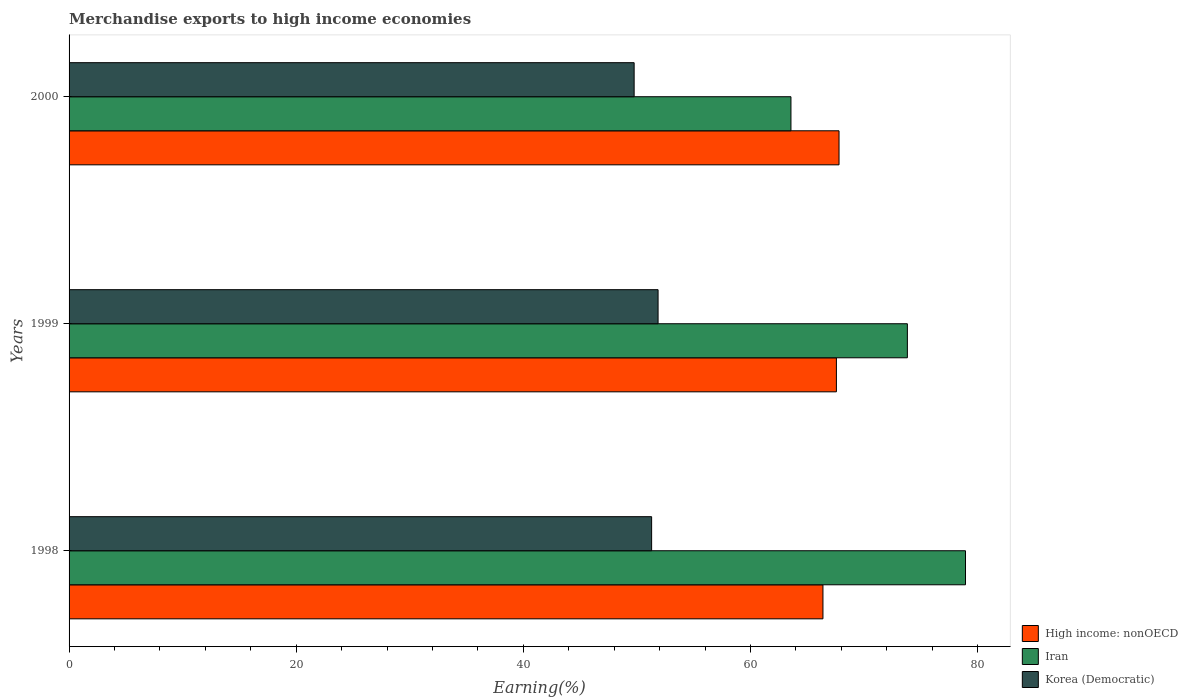How many bars are there on the 1st tick from the top?
Give a very brief answer. 3. What is the label of the 1st group of bars from the top?
Provide a succinct answer. 2000. In how many cases, is the number of bars for a given year not equal to the number of legend labels?
Offer a very short reply. 0. What is the percentage of amount earned from merchandise exports in Iran in 1998?
Keep it short and to the point. 78.93. Across all years, what is the maximum percentage of amount earned from merchandise exports in Korea (Democratic)?
Offer a terse response. 51.86. Across all years, what is the minimum percentage of amount earned from merchandise exports in Korea (Democratic)?
Your response must be concise. 49.75. What is the total percentage of amount earned from merchandise exports in Korea (Democratic) in the graph?
Offer a very short reply. 152.9. What is the difference between the percentage of amount earned from merchandise exports in High income: nonOECD in 1998 and that in 2000?
Your answer should be compact. -1.42. What is the difference between the percentage of amount earned from merchandise exports in Korea (Democratic) in 2000 and the percentage of amount earned from merchandise exports in High income: nonOECD in 1999?
Ensure brevity in your answer.  -17.81. What is the average percentage of amount earned from merchandise exports in High income: nonOECD per year?
Your answer should be compact. 67.24. In the year 1999, what is the difference between the percentage of amount earned from merchandise exports in Korea (Democratic) and percentage of amount earned from merchandise exports in High income: nonOECD?
Give a very brief answer. -15.7. What is the ratio of the percentage of amount earned from merchandise exports in Korea (Democratic) in 1998 to that in 1999?
Your response must be concise. 0.99. Is the difference between the percentage of amount earned from merchandise exports in Korea (Democratic) in 1999 and 2000 greater than the difference between the percentage of amount earned from merchandise exports in High income: nonOECD in 1999 and 2000?
Give a very brief answer. Yes. What is the difference between the highest and the second highest percentage of amount earned from merchandise exports in Korea (Democratic)?
Offer a very short reply. 0.57. What is the difference between the highest and the lowest percentage of amount earned from merchandise exports in Korea (Democratic)?
Keep it short and to the point. 2.11. Is the sum of the percentage of amount earned from merchandise exports in Korea (Democratic) in 1999 and 2000 greater than the maximum percentage of amount earned from merchandise exports in High income: nonOECD across all years?
Your response must be concise. Yes. What does the 2nd bar from the top in 2000 represents?
Offer a very short reply. Iran. What does the 1st bar from the bottom in 2000 represents?
Your answer should be very brief. High income: nonOECD. How many bars are there?
Your answer should be very brief. 9. How many years are there in the graph?
Give a very brief answer. 3. What is the difference between two consecutive major ticks on the X-axis?
Give a very brief answer. 20. Are the values on the major ticks of X-axis written in scientific E-notation?
Your answer should be compact. No. Does the graph contain grids?
Your answer should be compact. No. What is the title of the graph?
Offer a terse response. Merchandise exports to high income economies. Does "Panama" appear as one of the legend labels in the graph?
Offer a very short reply. No. What is the label or title of the X-axis?
Your answer should be very brief. Earning(%). What is the label or title of the Y-axis?
Provide a short and direct response. Years. What is the Earning(%) in High income: nonOECD in 1998?
Give a very brief answer. 66.38. What is the Earning(%) of Iran in 1998?
Ensure brevity in your answer.  78.93. What is the Earning(%) in Korea (Democratic) in 1998?
Your answer should be compact. 51.29. What is the Earning(%) in High income: nonOECD in 1999?
Your answer should be very brief. 67.56. What is the Earning(%) in Iran in 1999?
Ensure brevity in your answer.  73.81. What is the Earning(%) of Korea (Democratic) in 1999?
Your answer should be compact. 51.86. What is the Earning(%) of High income: nonOECD in 2000?
Ensure brevity in your answer.  67.79. What is the Earning(%) in Iran in 2000?
Provide a short and direct response. 63.56. What is the Earning(%) in Korea (Democratic) in 2000?
Offer a terse response. 49.75. Across all years, what is the maximum Earning(%) of High income: nonOECD?
Offer a terse response. 67.79. Across all years, what is the maximum Earning(%) in Iran?
Offer a very short reply. 78.93. Across all years, what is the maximum Earning(%) of Korea (Democratic)?
Provide a short and direct response. 51.86. Across all years, what is the minimum Earning(%) in High income: nonOECD?
Keep it short and to the point. 66.38. Across all years, what is the minimum Earning(%) in Iran?
Offer a terse response. 63.56. Across all years, what is the minimum Earning(%) of Korea (Democratic)?
Provide a short and direct response. 49.75. What is the total Earning(%) of High income: nonOECD in the graph?
Make the answer very short. 201.73. What is the total Earning(%) in Iran in the graph?
Offer a very short reply. 216.29. What is the total Earning(%) in Korea (Democratic) in the graph?
Keep it short and to the point. 152.9. What is the difference between the Earning(%) of High income: nonOECD in 1998 and that in 1999?
Your answer should be compact. -1.18. What is the difference between the Earning(%) in Iran in 1998 and that in 1999?
Provide a short and direct response. 5.12. What is the difference between the Earning(%) of Korea (Democratic) in 1998 and that in 1999?
Offer a very short reply. -0.57. What is the difference between the Earning(%) of High income: nonOECD in 1998 and that in 2000?
Offer a terse response. -1.42. What is the difference between the Earning(%) in Iran in 1998 and that in 2000?
Your response must be concise. 15.37. What is the difference between the Earning(%) in Korea (Democratic) in 1998 and that in 2000?
Offer a terse response. 1.54. What is the difference between the Earning(%) in High income: nonOECD in 1999 and that in 2000?
Give a very brief answer. -0.23. What is the difference between the Earning(%) of Iran in 1999 and that in 2000?
Your answer should be very brief. 10.25. What is the difference between the Earning(%) of Korea (Democratic) in 1999 and that in 2000?
Provide a short and direct response. 2.11. What is the difference between the Earning(%) of High income: nonOECD in 1998 and the Earning(%) of Iran in 1999?
Ensure brevity in your answer.  -7.43. What is the difference between the Earning(%) of High income: nonOECD in 1998 and the Earning(%) of Korea (Democratic) in 1999?
Offer a terse response. 14.52. What is the difference between the Earning(%) of Iran in 1998 and the Earning(%) of Korea (Democratic) in 1999?
Provide a short and direct response. 27.07. What is the difference between the Earning(%) of High income: nonOECD in 1998 and the Earning(%) of Iran in 2000?
Your response must be concise. 2.82. What is the difference between the Earning(%) of High income: nonOECD in 1998 and the Earning(%) of Korea (Democratic) in 2000?
Keep it short and to the point. 16.62. What is the difference between the Earning(%) in Iran in 1998 and the Earning(%) in Korea (Democratic) in 2000?
Offer a terse response. 29.17. What is the difference between the Earning(%) in High income: nonOECD in 1999 and the Earning(%) in Iran in 2000?
Make the answer very short. 4. What is the difference between the Earning(%) in High income: nonOECD in 1999 and the Earning(%) in Korea (Democratic) in 2000?
Keep it short and to the point. 17.81. What is the difference between the Earning(%) of Iran in 1999 and the Earning(%) of Korea (Democratic) in 2000?
Provide a succinct answer. 24.06. What is the average Earning(%) in High income: nonOECD per year?
Offer a very short reply. 67.24. What is the average Earning(%) in Iran per year?
Your response must be concise. 72.1. What is the average Earning(%) of Korea (Democratic) per year?
Your answer should be very brief. 50.97. In the year 1998, what is the difference between the Earning(%) in High income: nonOECD and Earning(%) in Iran?
Give a very brief answer. -12.55. In the year 1998, what is the difference between the Earning(%) in High income: nonOECD and Earning(%) in Korea (Democratic)?
Keep it short and to the point. 15.08. In the year 1998, what is the difference between the Earning(%) in Iran and Earning(%) in Korea (Democratic)?
Your answer should be compact. 27.63. In the year 1999, what is the difference between the Earning(%) in High income: nonOECD and Earning(%) in Iran?
Provide a short and direct response. -6.25. In the year 1999, what is the difference between the Earning(%) in High income: nonOECD and Earning(%) in Korea (Democratic)?
Offer a terse response. 15.7. In the year 1999, what is the difference between the Earning(%) of Iran and Earning(%) of Korea (Democratic)?
Your response must be concise. 21.95. In the year 2000, what is the difference between the Earning(%) in High income: nonOECD and Earning(%) in Iran?
Your answer should be very brief. 4.23. In the year 2000, what is the difference between the Earning(%) of High income: nonOECD and Earning(%) of Korea (Democratic)?
Your answer should be compact. 18.04. In the year 2000, what is the difference between the Earning(%) of Iran and Earning(%) of Korea (Democratic)?
Offer a very short reply. 13.81. What is the ratio of the Earning(%) in High income: nonOECD in 1998 to that in 1999?
Provide a short and direct response. 0.98. What is the ratio of the Earning(%) in Iran in 1998 to that in 1999?
Your response must be concise. 1.07. What is the ratio of the Earning(%) in High income: nonOECD in 1998 to that in 2000?
Make the answer very short. 0.98. What is the ratio of the Earning(%) in Iran in 1998 to that in 2000?
Offer a very short reply. 1.24. What is the ratio of the Earning(%) in Korea (Democratic) in 1998 to that in 2000?
Give a very brief answer. 1.03. What is the ratio of the Earning(%) in Iran in 1999 to that in 2000?
Your response must be concise. 1.16. What is the ratio of the Earning(%) of Korea (Democratic) in 1999 to that in 2000?
Provide a succinct answer. 1.04. What is the difference between the highest and the second highest Earning(%) of High income: nonOECD?
Make the answer very short. 0.23. What is the difference between the highest and the second highest Earning(%) of Iran?
Your answer should be very brief. 5.12. What is the difference between the highest and the second highest Earning(%) of Korea (Democratic)?
Keep it short and to the point. 0.57. What is the difference between the highest and the lowest Earning(%) of High income: nonOECD?
Your answer should be very brief. 1.42. What is the difference between the highest and the lowest Earning(%) in Iran?
Your answer should be compact. 15.37. What is the difference between the highest and the lowest Earning(%) of Korea (Democratic)?
Offer a terse response. 2.11. 